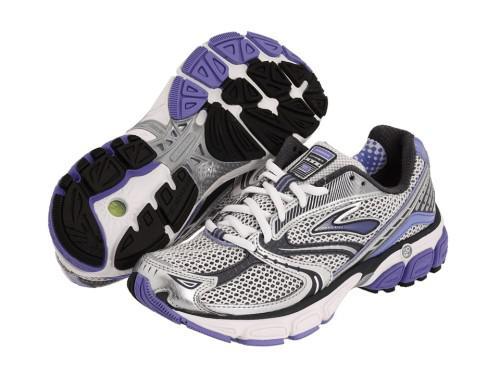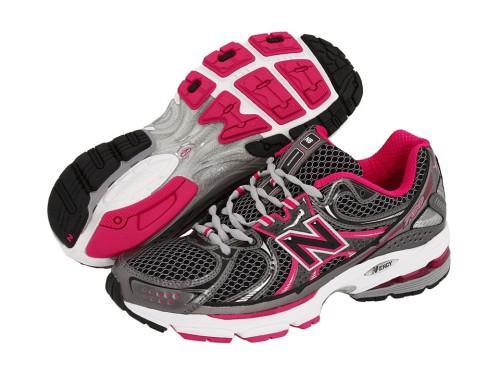The first image is the image on the left, the second image is the image on the right. For the images shown, is this caption "One image shows a pair of sneakers and the other shows a shoe pyramid." true? Answer yes or no. No. The first image is the image on the left, the second image is the image on the right. Given the left and right images, does the statement "Shoes are piled up together in the image on the right." hold true? Answer yes or no. No. 